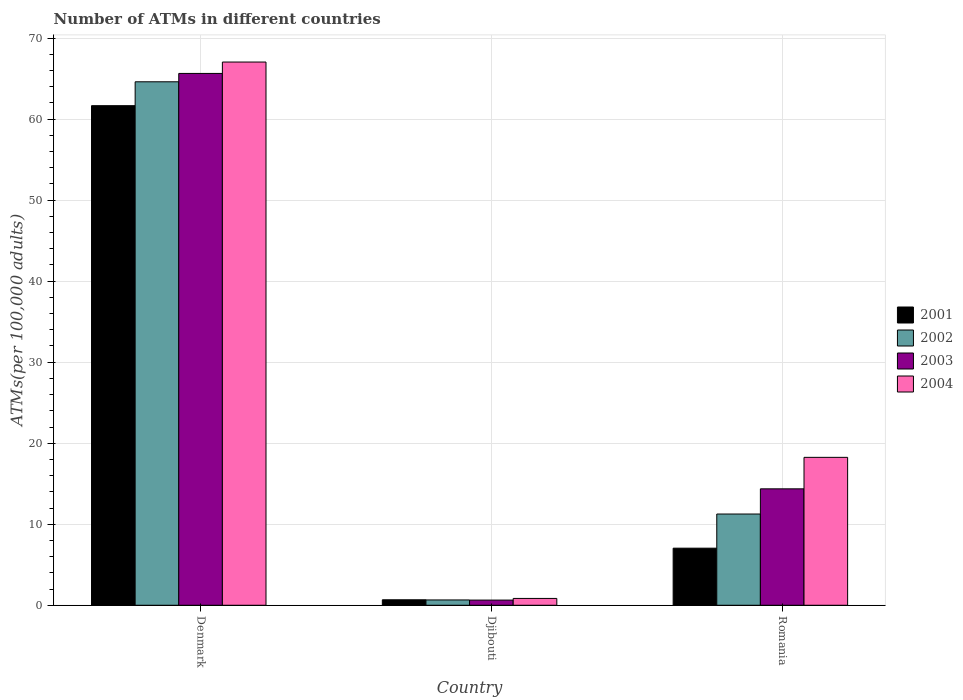How many different coloured bars are there?
Make the answer very short. 4. How many groups of bars are there?
Make the answer very short. 3. What is the label of the 3rd group of bars from the left?
Offer a terse response. Romania. What is the number of ATMs in 2001 in Denmark?
Ensure brevity in your answer.  61.66. Across all countries, what is the maximum number of ATMs in 2001?
Offer a terse response. 61.66. Across all countries, what is the minimum number of ATMs in 2004?
Offer a very short reply. 0.84. In which country was the number of ATMs in 2004 maximum?
Provide a succinct answer. Denmark. In which country was the number of ATMs in 2003 minimum?
Your response must be concise. Djibouti. What is the total number of ATMs in 2001 in the graph?
Offer a very short reply. 69.38. What is the difference between the number of ATMs in 2001 in Denmark and that in Romania?
Your answer should be compact. 54.61. What is the difference between the number of ATMs in 2004 in Romania and the number of ATMs in 2003 in Djibouti?
Offer a terse response. 17.62. What is the average number of ATMs in 2002 per country?
Provide a short and direct response. 25.51. What is the difference between the number of ATMs of/in 2001 and number of ATMs of/in 2003 in Denmark?
Offer a very short reply. -3.98. What is the ratio of the number of ATMs in 2002 in Denmark to that in Romania?
Your answer should be compact. 5.74. Is the number of ATMs in 2004 in Djibouti less than that in Romania?
Provide a short and direct response. Yes. Is the difference between the number of ATMs in 2001 in Denmark and Djibouti greater than the difference between the number of ATMs in 2003 in Denmark and Djibouti?
Provide a succinct answer. No. What is the difference between the highest and the second highest number of ATMs in 2002?
Provide a succinct answer. 63.95. What is the difference between the highest and the lowest number of ATMs in 2004?
Give a very brief answer. 66.2. Is the sum of the number of ATMs in 2001 in Denmark and Djibouti greater than the maximum number of ATMs in 2004 across all countries?
Keep it short and to the point. No. Is it the case that in every country, the sum of the number of ATMs in 2002 and number of ATMs in 2001 is greater than the sum of number of ATMs in 2004 and number of ATMs in 2003?
Ensure brevity in your answer.  No. Is it the case that in every country, the sum of the number of ATMs in 2001 and number of ATMs in 2002 is greater than the number of ATMs in 2004?
Ensure brevity in your answer.  Yes. How many bars are there?
Your response must be concise. 12. Are all the bars in the graph horizontal?
Offer a very short reply. No. What is the difference between two consecutive major ticks on the Y-axis?
Your answer should be compact. 10. Are the values on the major ticks of Y-axis written in scientific E-notation?
Your response must be concise. No. Does the graph contain any zero values?
Offer a very short reply. No. Where does the legend appear in the graph?
Offer a terse response. Center right. What is the title of the graph?
Make the answer very short. Number of ATMs in different countries. Does "1998" appear as one of the legend labels in the graph?
Your response must be concise. No. What is the label or title of the Y-axis?
Offer a very short reply. ATMs(per 100,0 adults). What is the ATMs(per 100,000 adults) in 2001 in Denmark?
Keep it short and to the point. 61.66. What is the ATMs(per 100,000 adults) of 2002 in Denmark?
Provide a short and direct response. 64.61. What is the ATMs(per 100,000 adults) of 2003 in Denmark?
Provide a succinct answer. 65.64. What is the ATMs(per 100,000 adults) of 2004 in Denmark?
Your response must be concise. 67.04. What is the ATMs(per 100,000 adults) in 2001 in Djibouti?
Provide a succinct answer. 0.68. What is the ATMs(per 100,000 adults) of 2002 in Djibouti?
Your answer should be compact. 0.66. What is the ATMs(per 100,000 adults) of 2003 in Djibouti?
Your response must be concise. 0.64. What is the ATMs(per 100,000 adults) of 2004 in Djibouti?
Your answer should be compact. 0.84. What is the ATMs(per 100,000 adults) of 2001 in Romania?
Your answer should be very brief. 7.04. What is the ATMs(per 100,000 adults) of 2002 in Romania?
Keep it short and to the point. 11.26. What is the ATMs(per 100,000 adults) of 2003 in Romania?
Your answer should be compact. 14.37. What is the ATMs(per 100,000 adults) in 2004 in Romania?
Your answer should be very brief. 18.26. Across all countries, what is the maximum ATMs(per 100,000 adults) of 2001?
Your response must be concise. 61.66. Across all countries, what is the maximum ATMs(per 100,000 adults) in 2002?
Keep it short and to the point. 64.61. Across all countries, what is the maximum ATMs(per 100,000 adults) in 2003?
Your response must be concise. 65.64. Across all countries, what is the maximum ATMs(per 100,000 adults) in 2004?
Ensure brevity in your answer.  67.04. Across all countries, what is the minimum ATMs(per 100,000 adults) of 2001?
Make the answer very short. 0.68. Across all countries, what is the minimum ATMs(per 100,000 adults) in 2002?
Provide a short and direct response. 0.66. Across all countries, what is the minimum ATMs(per 100,000 adults) in 2003?
Offer a very short reply. 0.64. Across all countries, what is the minimum ATMs(per 100,000 adults) of 2004?
Your answer should be compact. 0.84. What is the total ATMs(per 100,000 adults) of 2001 in the graph?
Offer a terse response. 69.38. What is the total ATMs(per 100,000 adults) of 2002 in the graph?
Your response must be concise. 76.52. What is the total ATMs(per 100,000 adults) of 2003 in the graph?
Ensure brevity in your answer.  80.65. What is the total ATMs(per 100,000 adults) of 2004 in the graph?
Your answer should be very brief. 86.14. What is the difference between the ATMs(per 100,000 adults) of 2001 in Denmark and that in Djibouti?
Offer a terse response. 60.98. What is the difference between the ATMs(per 100,000 adults) of 2002 in Denmark and that in Djibouti?
Give a very brief answer. 63.95. What is the difference between the ATMs(per 100,000 adults) of 2003 in Denmark and that in Djibouti?
Offer a terse response. 65. What is the difference between the ATMs(per 100,000 adults) in 2004 in Denmark and that in Djibouti?
Offer a terse response. 66.2. What is the difference between the ATMs(per 100,000 adults) of 2001 in Denmark and that in Romania?
Provide a short and direct response. 54.61. What is the difference between the ATMs(per 100,000 adults) of 2002 in Denmark and that in Romania?
Provide a short and direct response. 53.35. What is the difference between the ATMs(per 100,000 adults) in 2003 in Denmark and that in Romania?
Your response must be concise. 51.27. What is the difference between the ATMs(per 100,000 adults) in 2004 in Denmark and that in Romania?
Make the answer very short. 48.79. What is the difference between the ATMs(per 100,000 adults) of 2001 in Djibouti and that in Romania?
Keep it short and to the point. -6.37. What is the difference between the ATMs(per 100,000 adults) in 2002 in Djibouti and that in Romania?
Provide a short and direct response. -10.6. What is the difference between the ATMs(per 100,000 adults) in 2003 in Djibouti and that in Romania?
Your answer should be very brief. -13.73. What is the difference between the ATMs(per 100,000 adults) in 2004 in Djibouti and that in Romania?
Provide a succinct answer. -17.41. What is the difference between the ATMs(per 100,000 adults) in 2001 in Denmark and the ATMs(per 100,000 adults) in 2002 in Djibouti?
Ensure brevity in your answer.  61. What is the difference between the ATMs(per 100,000 adults) of 2001 in Denmark and the ATMs(per 100,000 adults) of 2003 in Djibouti?
Make the answer very short. 61.02. What is the difference between the ATMs(per 100,000 adults) of 2001 in Denmark and the ATMs(per 100,000 adults) of 2004 in Djibouti?
Offer a terse response. 60.81. What is the difference between the ATMs(per 100,000 adults) in 2002 in Denmark and the ATMs(per 100,000 adults) in 2003 in Djibouti?
Provide a succinct answer. 63.97. What is the difference between the ATMs(per 100,000 adults) of 2002 in Denmark and the ATMs(per 100,000 adults) of 2004 in Djibouti?
Provide a succinct answer. 63.76. What is the difference between the ATMs(per 100,000 adults) of 2003 in Denmark and the ATMs(per 100,000 adults) of 2004 in Djibouti?
Make the answer very short. 64.79. What is the difference between the ATMs(per 100,000 adults) in 2001 in Denmark and the ATMs(per 100,000 adults) in 2002 in Romania?
Provide a succinct answer. 50.4. What is the difference between the ATMs(per 100,000 adults) of 2001 in Denmark and the ATMs(per 100,000 adults) of 2003 in Romania?
Ensure brevity in your answer.  47.29. What is the difference between the ATMs(per 100,000 adults) in 2001 in Denmark and the ATMs(per 100,000 adults) in 2004 in Romania?
Offer a terse response. 43.4. What is the difference between the ATMs(per 100,000 adults) of 2002 in Denmark and the ATMs(per 100,000 adults) of 2003 in Romania?
Provide a short and direct response. 50.24. What is the difference between the ATMs(per 100,000 adults) in 2002 in Denmark and the ATMs(per 100,000 adults) in 2004 in Romania?
Give a very brief answer. 46.35. What is the difference between the ATMs(per 100,000 adults) in 2003 in Denmark and the ATMs(per 100,000 adults) in 2004 in Romania?
Provide a short and direct response. 47.38. What is the difference between the ATMs(per 100,000 adults) of 2001 in Djibouti and the ATMs(per 100,000 adults) of 2002 in Romania?
Make the answer very short. -10.58. What is the difference between the ATMs(per 100,000 adults) of 2001 in Djibouti and the ATMs(per 100,000 adults) of 2003 in Romania?
Keep it short and to the point. -13.69. What is the difference between the ATMs(per 100,000 adults) in 2001 in Djibouti and the ATMs(per 100,000 adults) in 2004 in Romania?
Your answer should be very brief. -17.58. What is the difference between the ATMs(per 100,000 adults) in 2002 in Djibouti and the ATMs(per 100,000 adults) in 2003 in Romania?
Your answer should be very brief. -13.71. What is the difference between the ATMs(per 100,000 adults) of 2002 in Djibouti and the ATMs(per 100,000 adults) of 2004 in Romania?
Ensure brevity in your answer.  -17.6. What is the difference between the ATMs(per 100,000 adults) in 2003 in Djibouti and the ATMs(per 100,000 adults) in 2004 in Romania?
Your response must be concise. -17.62. What is the average ATMs(per 100,000 adults) of 2001 per country?
Provide a short and direct response. 23.13. What is the average ATMs(per 100,000 adults) of 2002 per country?
Make the answer very short. 25.51. What is the average ATMs(per 100,000 adults) of 2003 per country?
Your response must be concise. 26.88. What is the average ATMs(per 100,000 adults) in 2004 per country?
Your response must be concise. 28.71. What is the difference between the ATMs(per 100,000 adults) of 2001 and ATMs(per 100,000 adults) of 2002 in Denmark?
Provide a short and direct response. -2.95. What is the difference between the ATMs(per 100,000 adults) in 2001 and ATMs(per 100,000 adults) in 2003 in Denmark?
Offer a terse response. -3.98. What is the difference between the ATMs(per 100,000 adults) of 2001 and ATMs(per 100,000 adults) of 2004 in Denmark?
Keep it short and to the point. -5.39. What is the difference between the ATMs(per 100,000 adults) in 2002 and ATMs(per 100,000 adults) in 2003 in Denmark?
Give a very brief answer. -1.03. What is the difference between the ATMs(per 100,000 adults) of 2002 and ATMs(per 100,000 adults) of 2004 in Denmark?
Your response must be concise. -2.44. What is the difference between the ATMs(per 100,000 adults) of 2003 and ATMs(per 100,000 adults) of 2004 in Denmark?
Ensure brevity in your answer.  -1.41. What is the difference between the ATMs(per 100,000 adults) in 2001 and ATMs(per 100,000 adults) in 2002 in Djibouti?
Offer a very short reply. 0.02. What is the difference between the ATMs(per 100,000 adults) of 2001 and ATMs(per 100,000 adults) of 2003 in Djibouti?
Ensure brevity in your answer.  0.04. What is the difference between the ATMs(per 100,000 adults) of 2001 and ATMs(per 100,000 adults) of 2004 in Djibouti?
Your response must be concise. -0.17. What is the difference between the ATMs(per 100,000 adults) of 2002 and ATMs(per 100,000 adults) of 2003 in Djibouti?
Provide a succinct answer. 0.02. What is the difference between the ATMs(per 100,000 adults) in 2002 and ATMs(per 100,000 adults) in 2004 in Djibouti?
Your response must be concise. -0.19. What is the difference between the ATMs(per 100,000 adults) in 2003 and ATMs(per 100,000 adults) in 2004 in Djibouti?
Offer a terse response. -0.21. What is the difference between the ATMs(per 100,000 adults) of 2001 and ATMs(per 100,000 adults) of 2002 in Romania?
Give a very brief answer. -4.21. What is the difference between the ATMs(per 100,000 adults) in 2001 and ATMs(per 100,000 adults) in 2003 in Romania?
Make the answer very short. -7.32. What is the difference between the ATMs(per 100,000 adults) in 2001 and ATMs(per 100,000 adults) in 2004 in Romania?
Provide a short and direct response. -11.21. What is the difference between the ATMs(per 100,000 adults) of 2002 and ATMs(per 100,000 adults) of 2003 in Romania?
Keep it short and to the point. -3.11. What is the difference between the ATMs(per 100,000 adults) in 2002 and ATMs(per 100,000 adults) in 2004 in Romania?
Provide a short and direct response. -7. What is the difference between the ATMs(per 100,000 adults) in 2003 and ATMs(per 100,000 adults) in 2004 in Romania?
Keep it short and to the point. -3.89. What is the ratio of the ATMs(per 100,000 adults) in 2001 in Denmark to that in Djibouti?
Give a very brief answer. 91.18. What is the ratio of the ATMs(per 100,000 adults) in 2002 in Denmark to that in Djibouti?
Provide a succinct answer. 98.45. What is the ratio of the ATMs(per 100,000 adults) of 2003 in Denmark to that in Djibouti?
Offer a very short reply. 102.88. What is the ratio of the ATMs(per 100,000 adults) of 2004 in Denmark to that in Djibouti?
Your answer should be compact. 79.46. What is the ratio of the ATMs(per 100,000 adults) of 2001 in Denmark to that in Romania?
Your answer should be very brief. 8.75. What is the ratio of the ATMs(per 100,000 adults) of 2002 in Denmark to that in Romania?
Offer a very short reply. 5.74. What is the ratio of the ATMs(per 100,000 adults) of 2003 in Denmark to that in Romania?
Ensure brevity in your answer.  4.57. What is the ratio of the ATMs(per 100,000 adults) in 2004 in Denmark to that in Romania?
Provide a short and direct response. 3.67. What is the ratio of the ATMs(per 100,000 adults) of 2001 in Djibouti to that in Romania?
Your answer should be compact. 0.1. What is the ratio of the ATMs(per 100,000 adults) of 2002 in Djibouti to that in Romania?
Offer a terse response. 0.06. What is the ratio of the ATMs(per 100,000 adults) of 2003 in Djibouti to that in Romania?
Your answer should be compact. 0.04. What is the ratio of the ATMs(per 100,000 adults) in 2004 in Djibouti to that in Romania?
Ensure brevity in your answer.  0.05. What is the difference between the highest and the second highest ATMs(per 100,000 adults) in 2001?
Give a very brief answer. 54.61. What is the difference between the highest and the second highest ATMs(per 100,000 adults) of 2002?
Offer a terse response. 53.35. What is the difference between the highest and the second highest ATMs(per 100,000 adults) of 2003?
Provide a short and direct response. 51.27. What is the difference between the highest and the second highest ATMs(per 100,000 adults) of 2004?
Ensure brevity in your answer.  48.79. What is the difference between the highest and the lowest ATMs(per 100,000 adults) in 2001?
Your answer should be compact. 60.98. What is the difference between the highest and the lowest ATMs(per 100,000 adults) in 2002?
Ensure brevity in your answer.  63.95. What is the difference between the highest and the lowest ATMs(per 100,000 adults) of 2003?
Provide a short and direct response. 65. What is the difference between the highest and the lowest ATMs(per 100,000 adults) of 2004?
Provide a succinct answer. 66.2. 